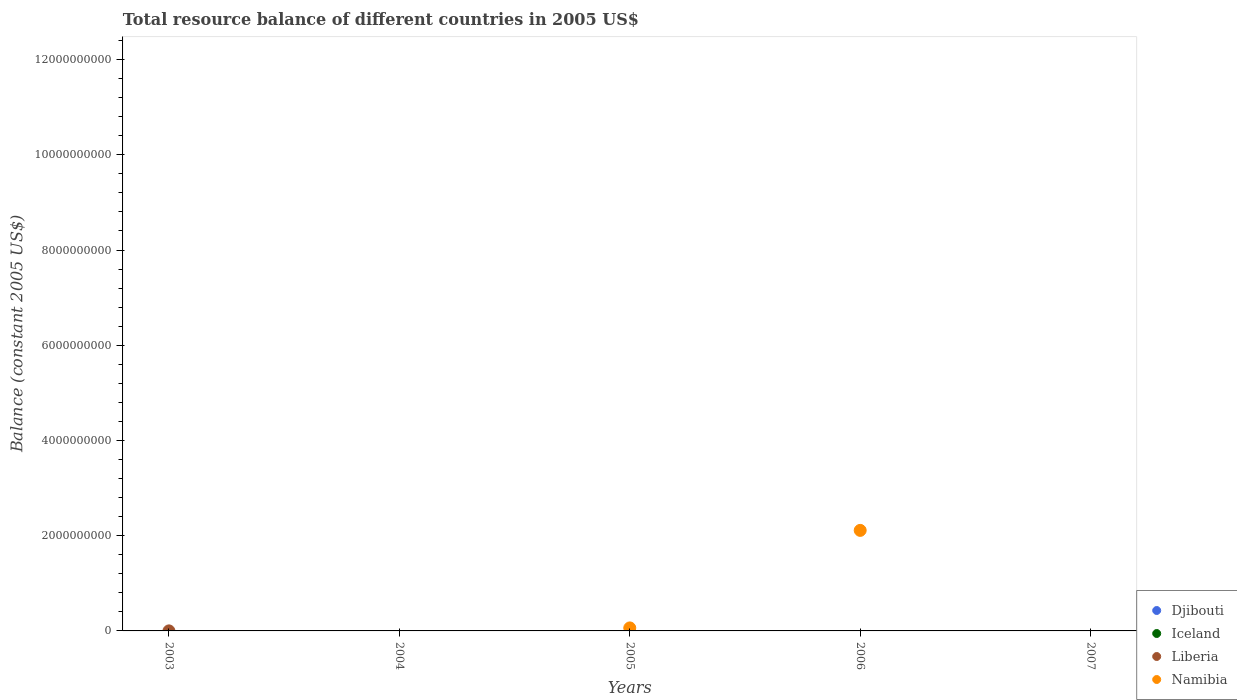How many different coloured dotlines are there?
Your answer should be compact. 2. What is the total resource balance in Djibouti in 2006?
Provide a short and direct response. 0. Across all years, what is the maximum total resource balance in Liberia?
Provide a short and direct response. 8.06e+05. In which year was the total resource balance in Liberia maximum?
Your response must be concise. 2003. What is the total total resource balance in Liberia in the graph?
Your answer should be compact. 8.06e+05. What is the difference between the total resource balance in Namibia in 2005 and that in 2006?
Offer a terse response. -2.05e+09. What is the average total resource balance in Liberia per year?
Provide a succinct answer. 1.61e+05. In how many years, is the total resource balance in Namibia greater than 10400000000 US$?
Make the answer very short. 0. What is the difference between the highest and the lowest total resource balance in Liberia?
Offer a very short reply. 8.06e+05. Is it the case that in every year, the sum of the total resource balance in Iceland and total resource balance in Liberia  is greater than the total resource balance in Namibia?
Offer a very short reply. No. Does the total resource balance in Iceland monotonically increase over the years?
Your response must be concise. No. Is the total resource balance in Liberia strictly less than the total resource balance in Iceland over the years?
Give a very brief answer. No. How many dotlines are there?
Your answer should be very brief. 2. Does the graph contain any zero values?
Provide a short and direct response. Yes. How many legend labels are there?
Ensure brevity in your answer.  4. How are the legend labels stacked?
Your answer should be compact. Vertical. What is the title of the graph?
Ensure brevity in your answer.  Total resource balance of different countries in 2005 US$. What is the label or title of the Y-axis?
Ensure brevity in your answer.  Balance (constant 2005 US$). What is the Balance (constant 2005 US$) in Iceland in 2003?
Keep it short and to the point. 0. What is the Balance (constant 2005 US$) in Liberia in 2003?
Make the answer very short. 8.06e+05. What is the Balance (constant 2005 US$) in Namibia in 2003?
Your answer should be compact. 0. What is the Balance (constant 2005 US$) in Djibouti in 2004?
Provide a short and direct response. 0. What is the Balance (constant 2005 US$) of Liberia in 2004?
Ensure brevity in your answer.  0. What is the Balance (constant 2005 US$) in Djibouti in 2005?
Make the answer very short. 0. What is the Balance (constant 2005 US$) in Namibia in 2005?
Offer a very short reply. 6.32e+07. What is the Balance (constant 2005 US$) of Iceland in 2006?
Your answer should be compact. 0. What is the Balance (constant 2005 US$) in Liberia in 2006?
Provide a succinct answer. 0. What is the Balance (constant 2005 US$) of Namibia in 2006?
Provide a succinct answer. 2.11e+09. What is the Balance (constant 2005 US$) in Djibouti in 2007?
Your response must be concise. 0. What is the Balance (constant 2005 US$) in Iceland in 2007?
Your answer should be very brief. 0. What is the Balance (constant 2005 US$) in Namibia in 2007?
Provide a succinct answer. 0. Across all years, what is the maximum Balance (constant 2005 US$) in Liberia?
Your answer should be compact. 8.06e+05. Across all years, what is the maximum Balance (constant 2005 US$) of Namibia?
Keep it short and to the point. 2.11e+09. Across all years, what is the minimum Balance (constant 2005 US$) in Liberia?
Your response must be concise. 0. What is the total Balance (constant 2005 US$) in Liberia in the graph?
Offer a very short reply. 8.06e+05. What is the total Balance (constant 2005 US$) in Namibia in the graph?
Ensure brevity in your answer.  2.17e+09. What is the difference between the Balance (constant 2005 US$) of Namibia in 2005 and that in 2006?
Offer a terse response. -2.05e+09. What is the difference between the Balance (constant 2005 US$) of Liberia in 2003 and the Balance (constant 2005 US$) of Namibia in 2005?
Offer a very short reply. -6.24e+07. What is the difference between the Balance (constant 2005 US$) in Liberia in 2003 and the Balance (constant 2005 US$) in Namibia in 2006?
Provide a succinct answer. -2.11e+09. What is the average Balance (constant 2005 US$) of Liberia per year?
Keep it short and to the point. 1.61e+05. What is the average Balance (constant 2005 US$) in Namibia per year?
Your response must be concise. 4.35e+08. What is the ratio of the Balance (constant 2005 US$) of Namibia in 2005 to that in 2006?
Offer a very short reply. 0.03. What is the difference between the highest and the lowest Balance (constant 2005 US$) of Liberia?
Offer a very short reply. 8.06e+05. What is the difference between the highest and the lowest Balance (constant 2005 US$) of Namibia?
Provide a short and direct response. 2.11e+09. 